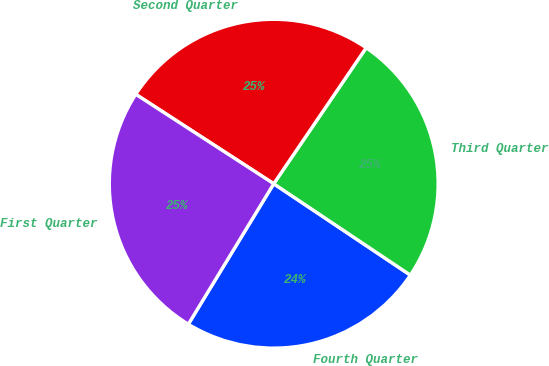<chart> <loc_0><loc_0><loc_500><loc_500><pie_chart><fcel>Fourth Quarter<fcel>Third Quarter<fcel>Second Quarter<fcel>First Quarter<nl><fcel>24.31%<fcel>24.88%<fcel>25.35%<fcel>25.46%<nl></chart> 